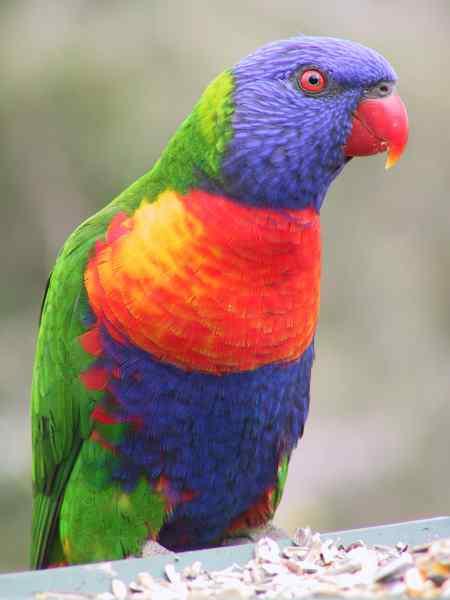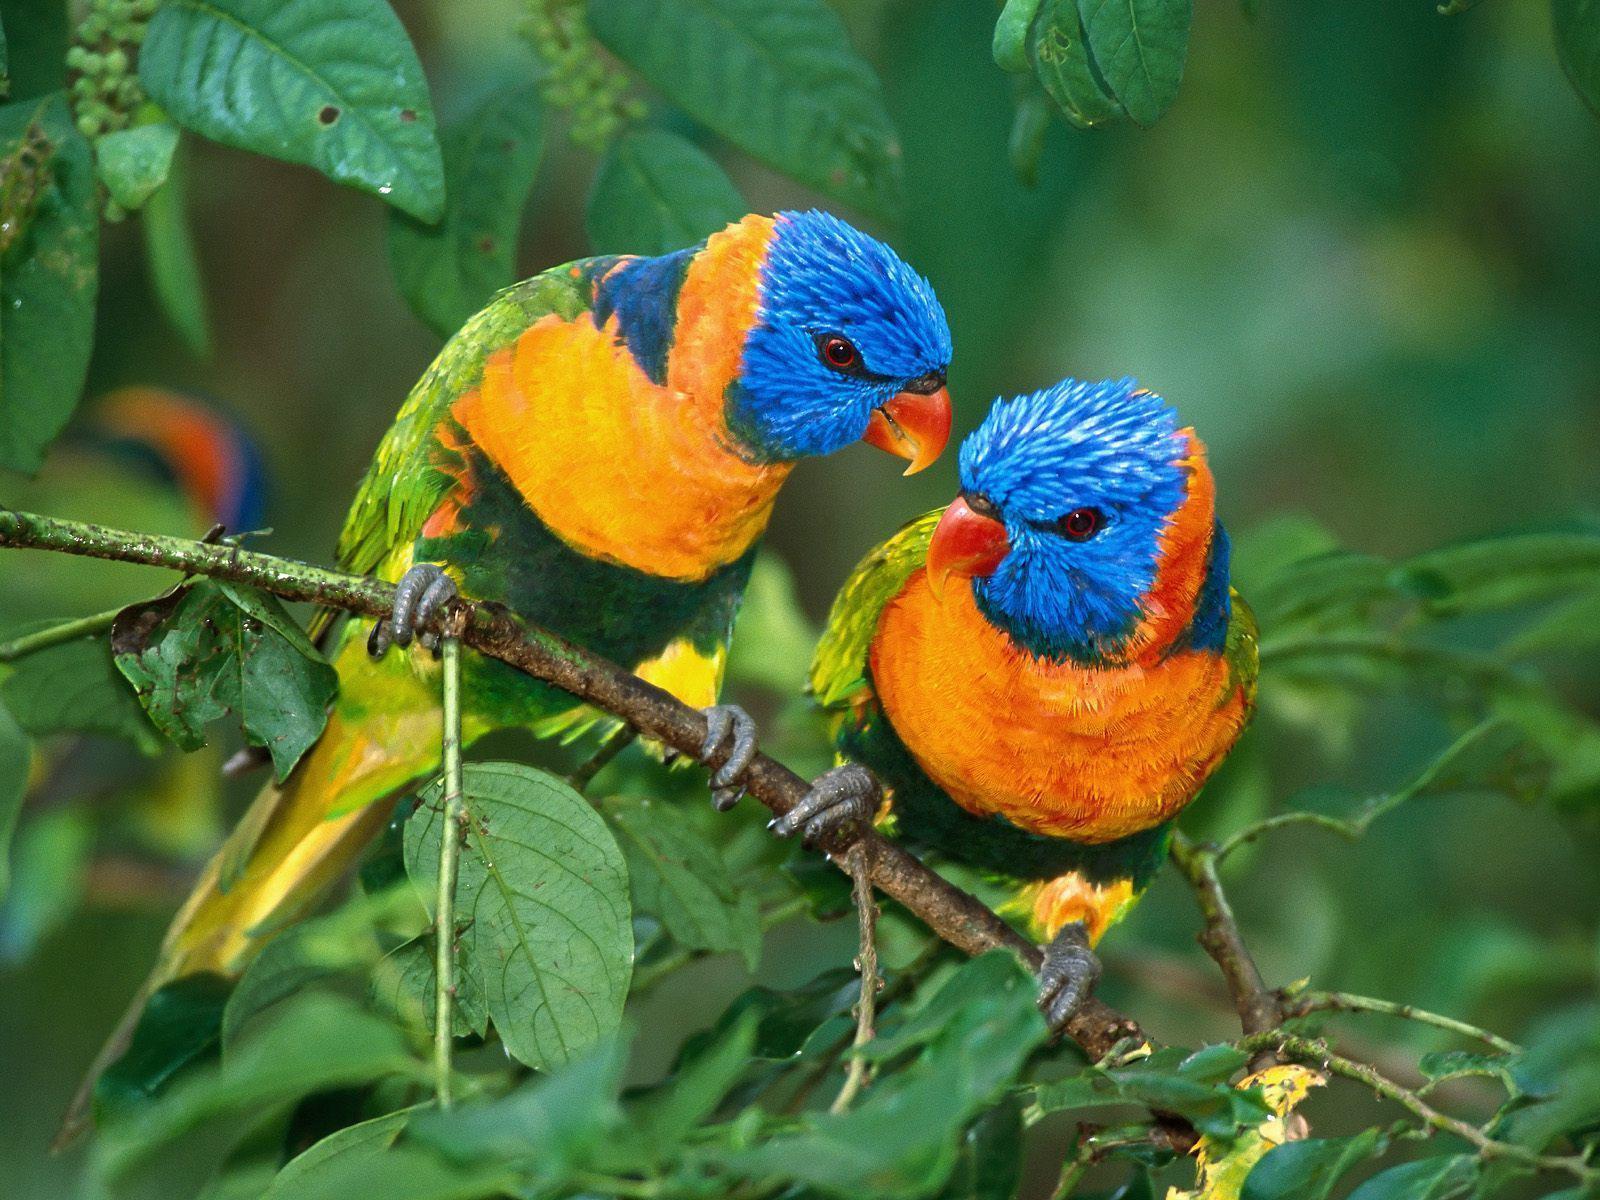The first image is the image on the left, the second image is the image on the right. For the images displayed, is the sentence "There are more parrots in the left image." factually correct? Answer yes or no. No. 